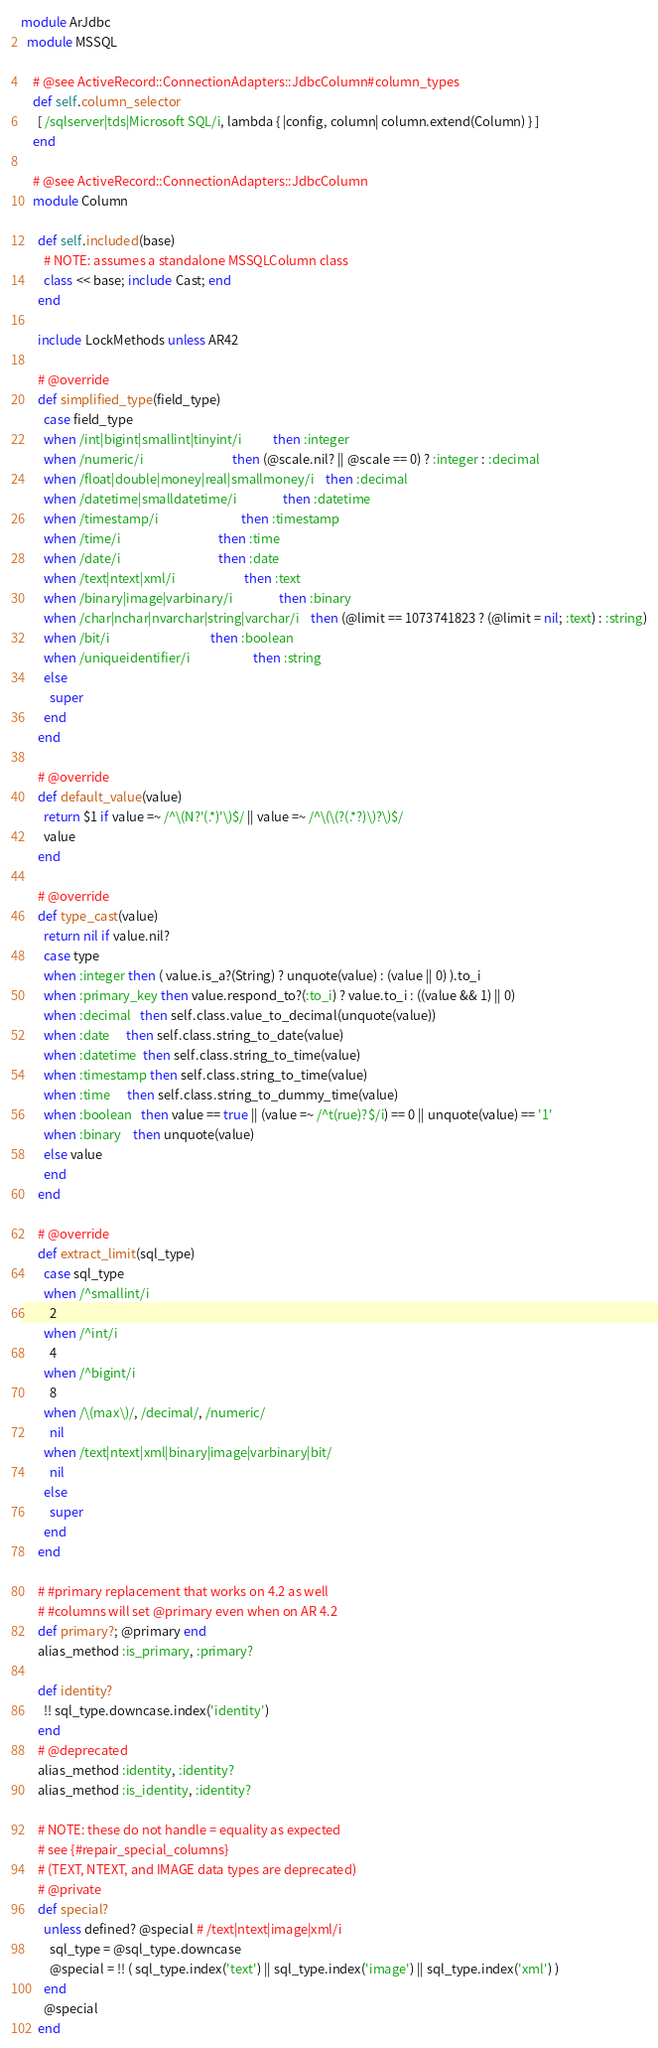<code> <loc_0><loc_0><loc_500><loc_500><_Ruby_>module ArJdbc
  module MSSQL

    # @see ActiveRecord::ConnectionAdapters::JdbcColumn#column_types
    def self.column_selector
      [ /sqlserver|tds|Microsoft SQL/i, lambda { |config, column| column.extend(Column) } ]
    end

    # @see ActiveRecord::ConnectionAdapters::JdbcColumn
    module Column

      def self.included(base)
        # NOTE: assumes a standalone MSSQLColumn class
        class << base; include Cast; end
      end

      include LockMethods unless AR42

      # @override
      def simplified_type(field_type)
        case field_type
        when /int|bigint|smallint|tinyint/i           then :integer
        when /numeric/i                               then (@scale.nil? || @scale == 0) ? :integer : :decimal
        when /float|double|money|real|smallmoney/i    then :decimal
        when /datetime|smalldatetime/i                then :datetime
        when /timestamp/i                             then :timestamp
        when /time/i                                  then :time
        when /date/i                                  then :date
        when /text|ntext|xml/i                        then :text
        when /binary|image|varbinary/i                then :binary
        when /char|nchar|nvarchar|string|varchar/i    then (@limit == 1073741823 ? (@limit = nil; :text) : :string)
        when /bit/i                                   then :boolean
        when /uniqueidentifier/i                      then :string
        else
          super
        end
      end

      # @override
      def default_value(value)
        return $1 if value =~ /^\(N?'(.*)'\)$/ || value =~ /^\(\(?(.*?)\)?\)$/
        value
      end

      # @override
      def type_cast(value)
        return nil if value.nil?
        case type
        when :integer then ( value.is_a?(String) ? unquote(value) : (value || 0) ).to_i
        when :primary_key then value.respond_to?(:to_i) ? value.to_i : ((value && 1) || 0)
        when :decimal   then self.class.value_to_decimal(unquote(value))
        when :date      then self.class.string_to_date(value)
        when :datetime  then self.class.string_to_time(value)
        when :timestamp then self.class.string_to_time(value)
        when :time      then self.class.string_to_dummy_time(value)
        when :boolean   then value == true || (value =~ /^t(rue)?$/i) == 0 || unquote(value) == '1'
        when :binary    then unquote(value)
        else value
        end
      end

      # @override
      def extract_limit(sql_type)
        case sql_type
        when /^smallint/i
          2
        when /^int/i
          4
        when /^bigint/i
          8
        when /\(max\)/, /decimal/, /numeric/
          nil
        when /text|ntext|xml|binary|image|varbinary|bit/
          nil
        else
          super
        end
      end

      # #primary replacement that works on 4.2 as well
      # #columns will set @primary even when on AR 4.2
      def primary?; @primary end
      alias_method :is_primary, :primary?

      def identity?
        !! sql_type.downcase.index('identity')
      end
      # @deprecated
      alias_method :identity, :identity?
      alias_method :is_identity, :identity?

      # NOTE: these do not handle = equality as expected
      # see {#repair_special_columns}
      # (TEXT, NTEXT, and IMAGE data types are deprecated)
      # @private
      def special?
        unless defined? @special # /text|ntext|image|xml/i
          sql_type = @sql_type.downcase
          @special = !! ( sql_type.index('text') || sql_type.index('image') || sql_type.index('xml') )
        end
        @special
      end</code> 